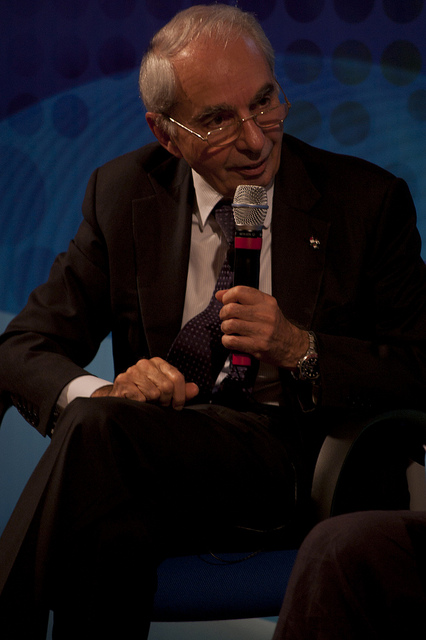<image>What type of flower is covering the man's face? There is no flower covering the man's face. What type of flower is covering the man's face? There is no flower covering the man's face in the image. 